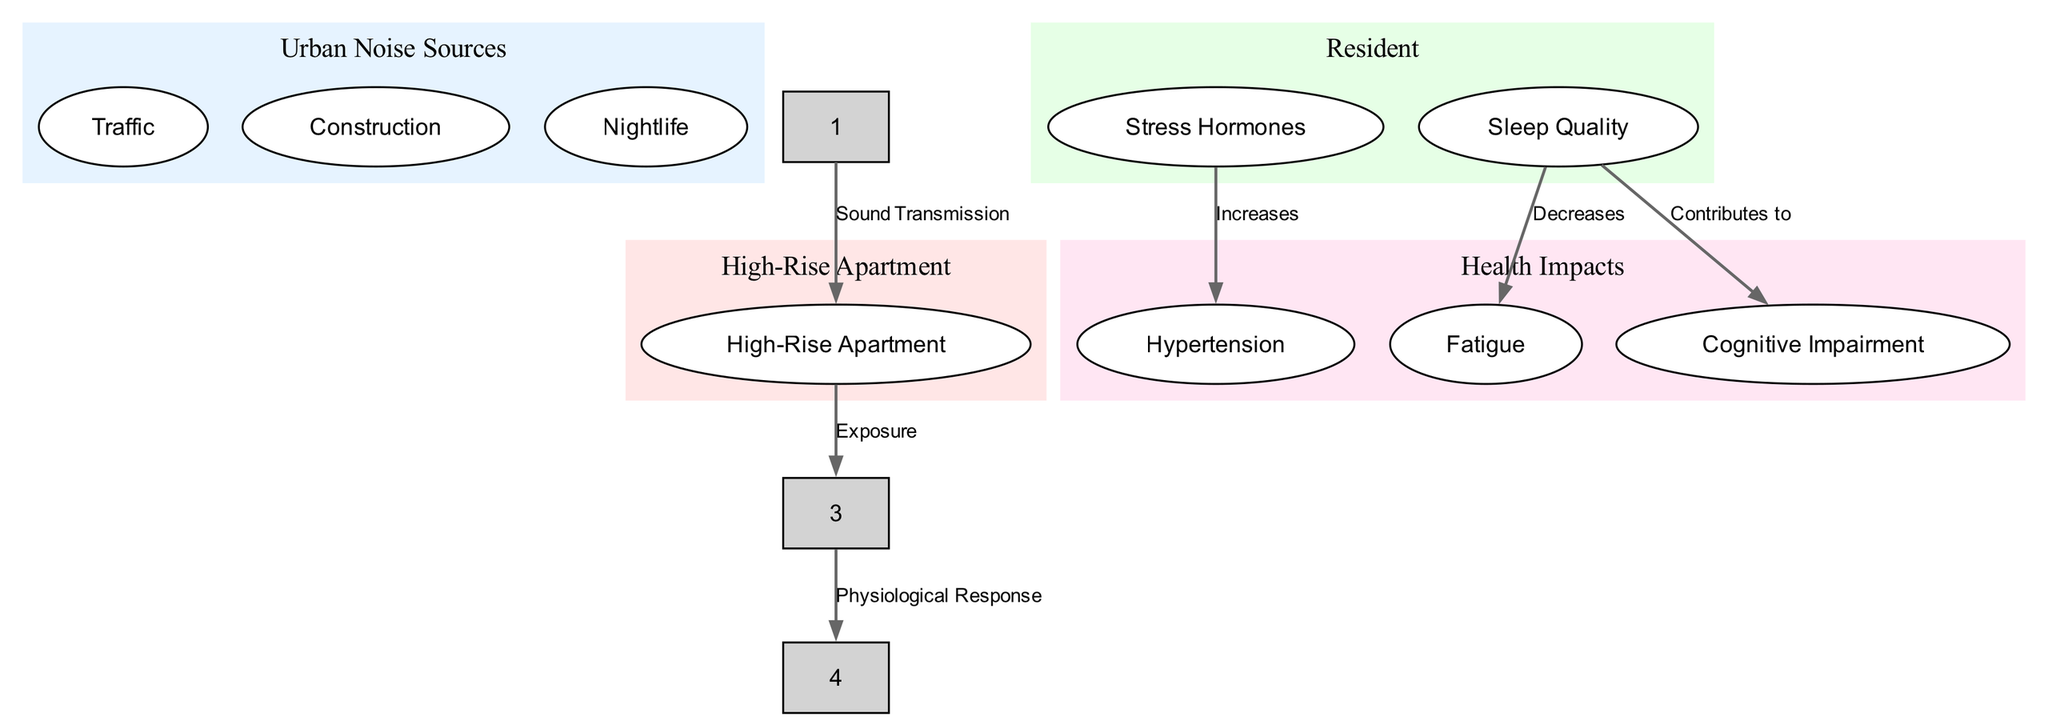What are the three urban noise sources? The diagram lists three urban noise sources under the "Urban Noise Sources" node: Traffic, Construction, and Nightlife.
Answer: Traffic, Construction, Nightlife How many health impacts are listed in the diagram? Under the "Health Impacts" node, there are three listed impacts: Hypertension, Fatigue, and Cognitive Impairment. Therefore, the total number is three.
Answer: 3 What is the relationship between the "Resident" and "High-Rise Apartment" nodes? The diagram depicts that the relationship is defined by the edge labeled "Exposure", indicating that residents are exposed to conditions within high-rise apartments.
Answer: Exposure Which hormone level increases due to urban noise pollution? The diagram indicates that "Stress Hormones" increase as a physiological response to urban noise pollution, leading to various health impacts.
Answer: Stress Hormones What health impact is contributed to by decreased sleep quality? According to the diagram, decreased sleep quality contributes to "Cognitive Impairment," linking sleep issues directly to cognitive health.
Answer: Cognitive Impairment What type of noise is the primary source listed in this diagram? The primary type referenced is "Urban Noise," which encompasses specific sources such as Traffic, Construction, and Nightlife, all contributing to the overall impact on residents.
Answer: Urban Noise Which health impact is associated with increased stress hormones? The diagram specifies that increased levels of stress hormones are associated with "Hypertension," indicating a direct connection between these two aspects.
Answer: Hypertension Which node represents a physiological response in the diagram? The "Resident" node encompasses both stress hormones and sleep quality, which influence health impacts; thus it is the pivotal node representing a physiological response.
Answer: Resident 